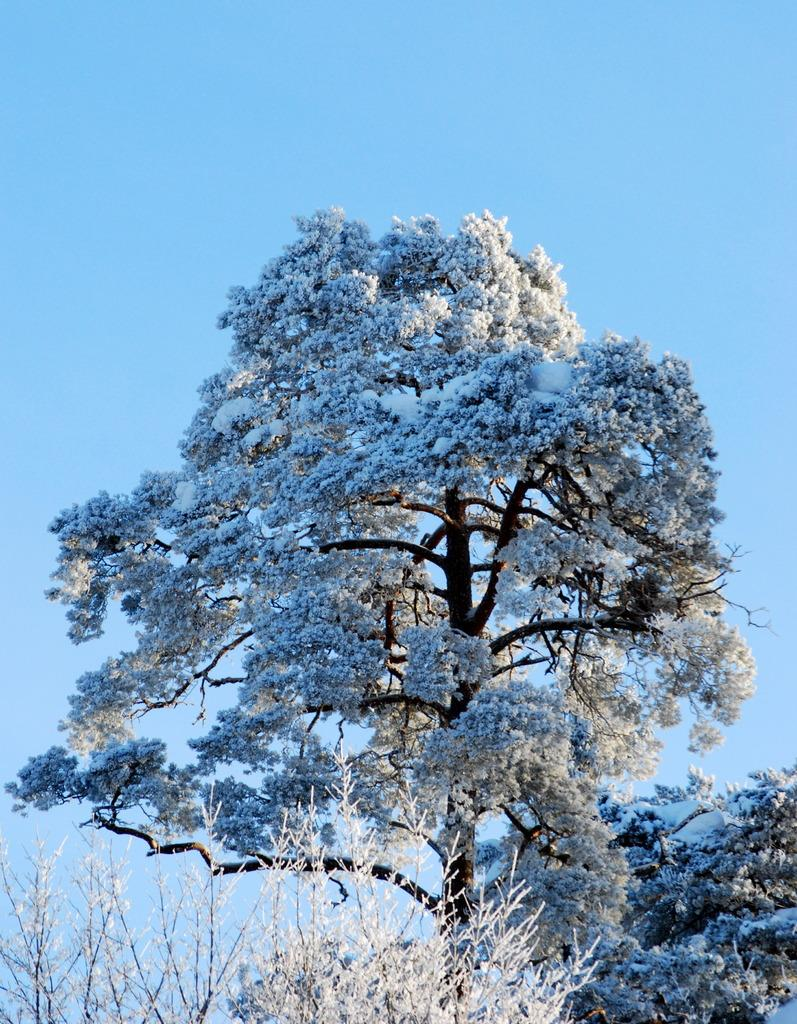What type of vegetation can be seen in the image? There are trees and plants in the image. How is the vegetation affected by the weather in the image? Snow is present on the trees and plants in the image. What can be seen behind the trees in the image? The sky is visible behind the trees in the image. What type of animals can be seen at the zoo in the image? There is no zoo present in the image; it features trees and plants covered in snow. What game is being played in the image? There is no game being played in the image; it shows a snowy landscape with trees and plants. 